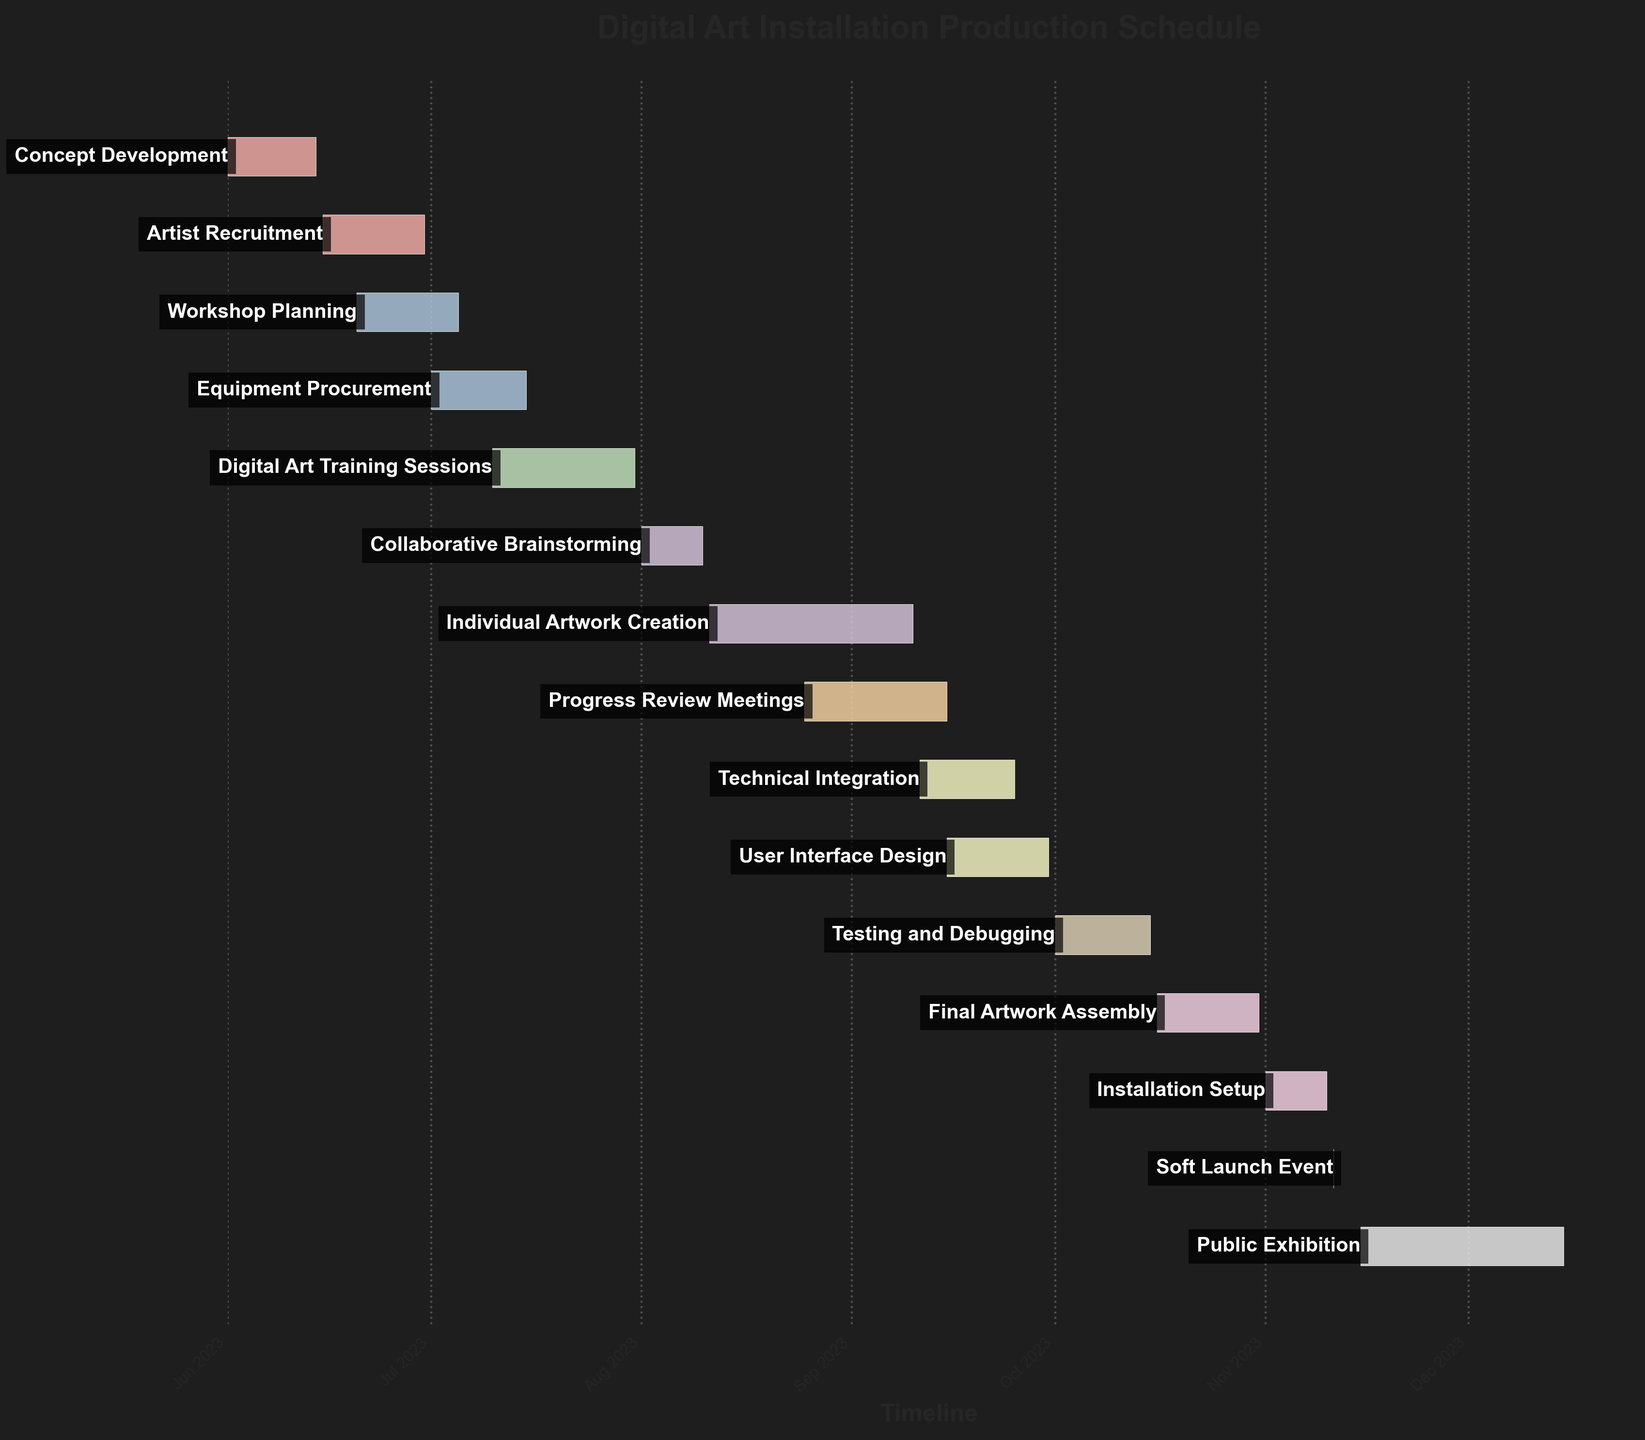What is the title of the chart? The title of the chart is located at the top center and is the most prominent text in the chart. It is usually written in a larger font size and bold style.
Answer: Digital Art Installation Production Schedule How many tasks are there in total? Count the number of bars listed in the Gantt chart, as each bar represents one task.
Answer: 15 Which task begins immediately after 'Concept Development'? Look at the bar representing 'Concept Development' and identify the task that starts right after its end date.
Answer: Artist Recruitment On what date does 'Testing and Debugging' finish? Check the end date for the 'Testing and Debugging' task bar.
Answer: 2023-10-15 What are the starting and ending dates for the task 'Collaborative Brainstorming'? Locate the bar for 'Collaborative Brainstorming' and read the start and end dates displayed with it.
Answer: 2023-08-01 to 2023-08-10 Which tasks overlap with 'Digital Art Training Sessions'? Observe the time frame for 'Digital Art Training Sessions' and identify other tasks whose timelines overlap with this period. Look at their start and end dates.
Answer: Equipment Procurement and Collaborative Brainstorming How many days long is 'Public Exhibition'? Look at the duration or calculate the number of days from the start date to the end date for 'Public Exhibition'.
Answer: 31 days Which task has the shortest duration? Compare the duration of all task bars and find the one with the smallest number of days.
Answer: Soft Launch Event Compare the duration of 'Individual Artwork Creation' and 'Progress Review Meetings'. Which one is longer and by how many days? Look at the duration for both tasks and subtract the shorter one from the longer one to find the difference. 'Individual Artwork Creation' is 31 days, and 'Progress Review Meetings' is 22 days. 31 - 22 = 9 days.
Answer: Individual Artwork Creation is longer by 9 days What is the total duration from 'Concept Development' to 'Final Artwork Assembly'? Determine the start date of 'Concept Development' and the end date of 'Final Artwork Assembly', then count the total days between these two dates.
Answer: 2023-06-01 to 2023-10-31 (153 days) Overall, which months have the most ongoing tasks? Look at the distribution of the tasks' bars across the months and see which months have the highest number of overlapping bars.
Answer: August and September 